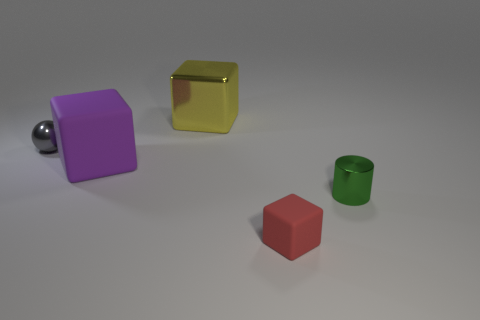Subtract all large blocks. How many blocks are left? 1 Add 5 green metal objects. How many objects exist? 10 Subtract all cubes. How many objects are left? 2 Add 2 red matte objects. How many red matte objects exist? 3 Subtract 0 cyan spheres. How many objects are left? 5 Subtract all tiny spheres. Subtract all matte objects. How many objects are left? 2 Add 4 large purple things. How many large purple things are left? 5 